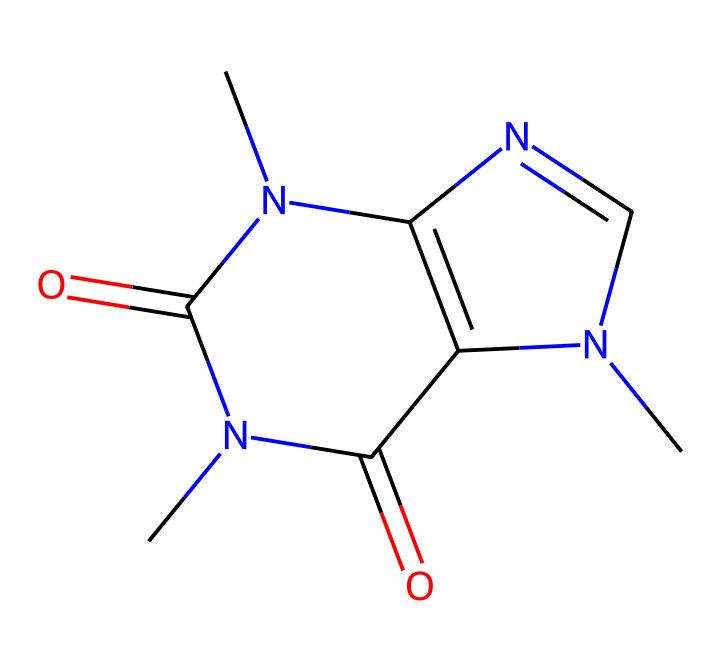how many nitrogen atoms are present in this chemical? By analyzing the SMILES representation, we can count the nitrogen atoms, which are denoted by "N" in the structure. There are three instances of "N" in the SMILES.
Answer: three what is the molecular formula of this chemical? The SMILES can be translated into a molecular formula by identifying the number of each type of atom. In this case, there are 8 carbon atoms (C), 10 hydrogen atoms (H), 4 nitrogen atoms (N), and 2 oxygen atoms (O), giving us the molecular formula C8H10N4O2.
Answer: C8H10N4O2 is this chemical a stimulant? Caffeine is known as a stimulant, contributing to increased alertness and productivity, particularly during activities like coding. This classification is based on the effects associated with the chemical structure and its biological activity.
Answer: yes what type of drug does this chemical represent? The chemical is classified as a central nervous system stimulant due to its ability to enhance alertness and reduce fatigue, particularly relevant for activities involving prolonged concentration such as coding.
Answer: stimulant how does this chemical affect productivity during coding marathons? Caffeine works by antagonizing adenosine receptors, leading to increased neuronal firing and the release of neurotransmitters like dopamine and norepinephrine. This boosts alertness, concentration, and overall productivity, vital for sustained mental performance during coding tasks.
Answer: increases concentration 